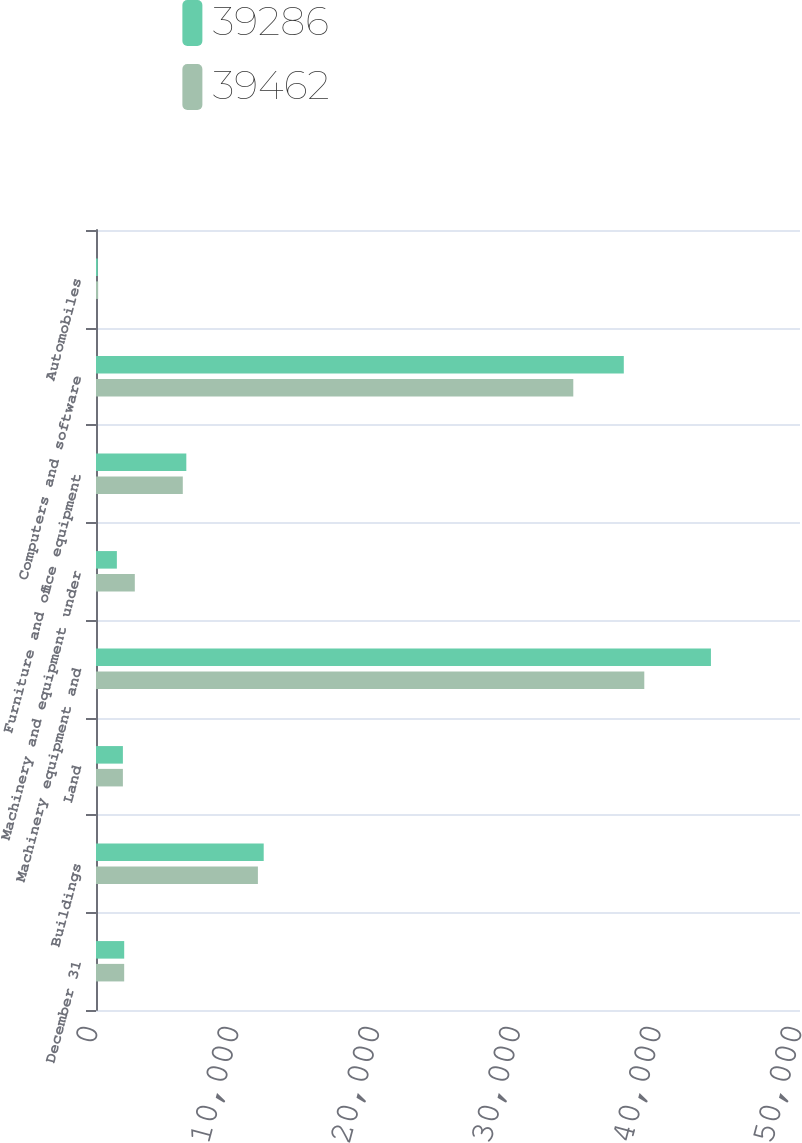Convert chart to OTSL. <chart><loc_0><loc_0><loc_500><loc_500><stacked_bar_chart><ecel><fcel>December 31<fcel>Buildings<fcel>Land<fcel>Machinery equipment and<fcel>Machinery and equipment under<fcel>Furniture and office equipment<fcel>Computers and software<fcel>Automobiles<nl><fcel>39286<fcel>2003<fcel>11911<fcel>1910<fcel>43674<fcel>1482<fcel>6415<fcel>37486<fcel>128<nl><fcel>39462<fcel>2002<fcel>11499<fcel>1910<fcel>38941<fcel>2757<fcel>6164<fcel>33899<fcel>153<nl></chart> 